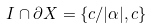Convert formula to latex. <formula><loc_0><loc_0><loc_500><loc_500>I \cap \partial X = \{ c / | \alpha | , c \}</formula> 